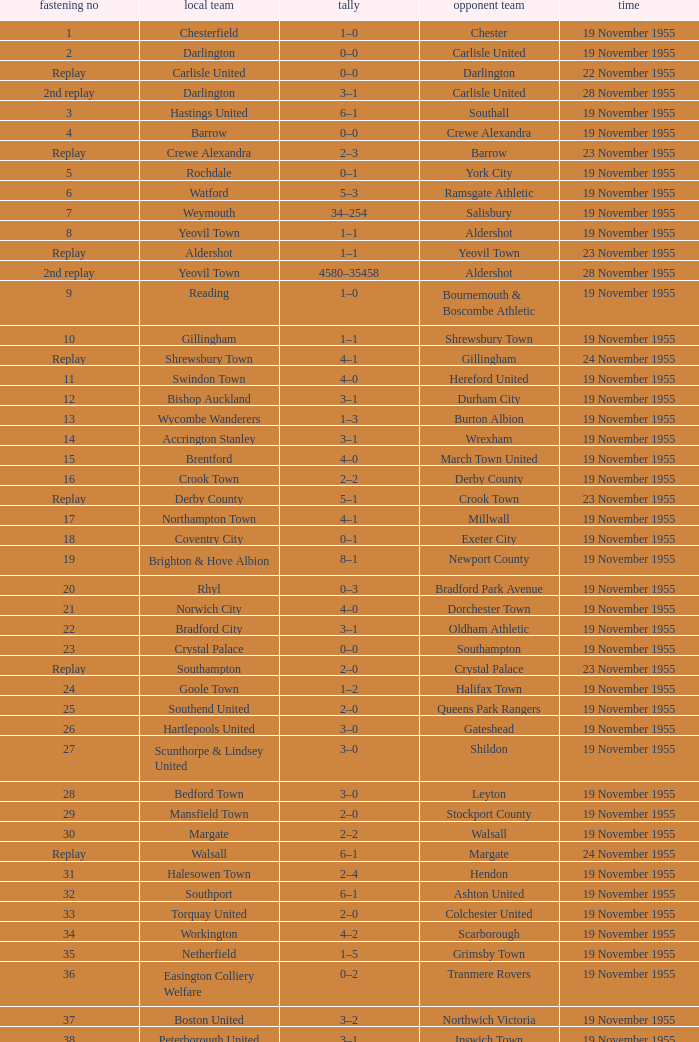What is the away team with a 5 tie no? York City. 